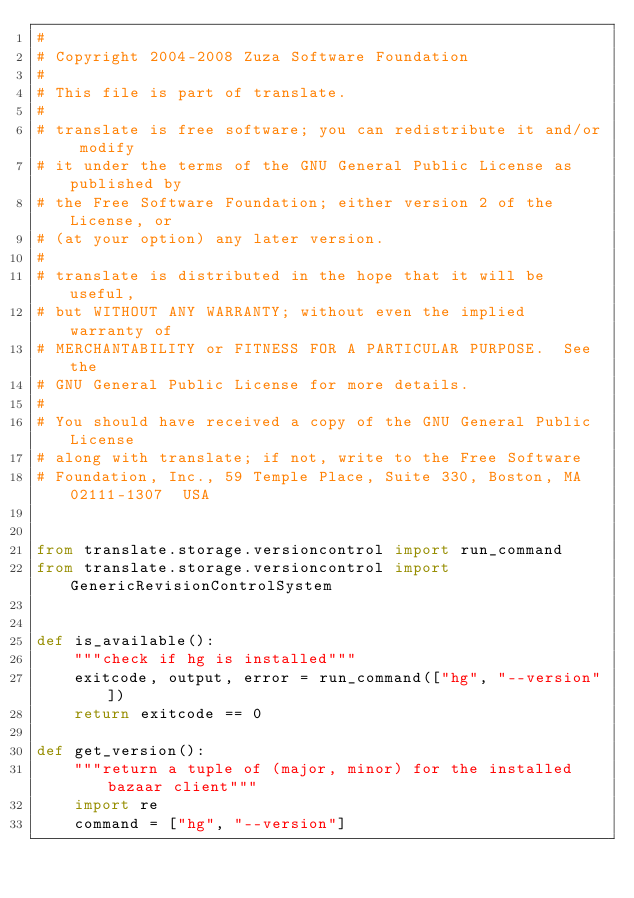<code> <loc_0><loc_0><loc_500><loc_500><_Python_># 
# Copyright 2004-2008 Zuza Software Foundation
# 
# This file is part of translate.
#
# translate is free software; you can redistribute it and/or modify
# it under the terms of the GNU General Public License as published by
# the Free Software Foundation; either version 2 of the License, or
# (at your option) any later version.
# 
# translate is distributed in the hope that it will be useful,
# but WITHOUT ANY WARRANTY; without even the implied warranty of
# MERCHANTABILITY or FITNESS FOR A PARTICULAR PURPOSE.  See the
# GNU General Public License for more details.
#
# You should have received a copy of the GNU General Public License
# along with translate; if not, write to the Free Software
# Foundation, Inc., 59 Temple Place, Suite 330, Boston, MA  02111-1307  USA


from translate.storage.versioncontrol import run_command
from translate.storage.versioncontrol import GenericRevisionControlSystem


def is_available():
    """check if hg is installed"""
    exitcode, output, error = run_command(["hg", "--version"])
    return exitcode == 0

def get_version():
    """return a tuple of (major, minor) for the installed bazaar client"""
    import re
    command = ["hg", "--version"]</code> 